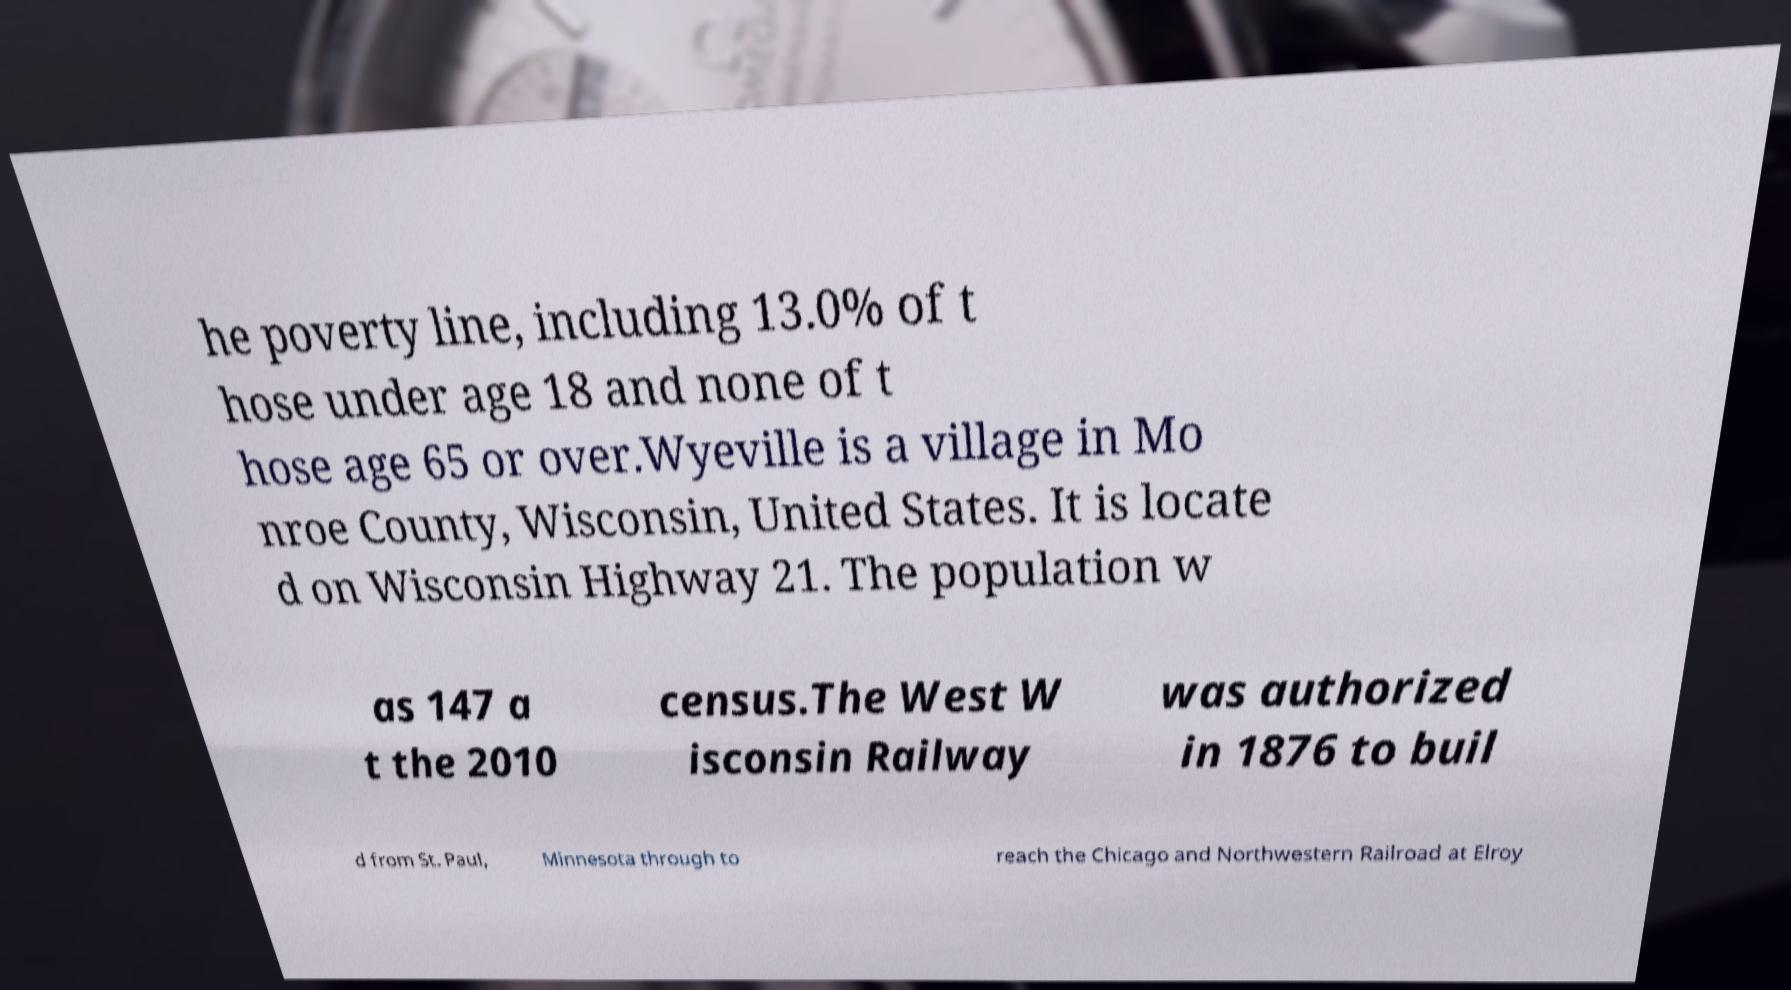Could you extract and type out the text from this image? he poverty line, including 13.0% of t hose under age 18 and none of t hose age 65 or over.Wyeville is a village in Mo nroe County, Wisconsin, United States. It is locate d on Wisconsin Highway 21. The population w as 147 a t the 2010 census.The West W isconsin Railway was authorized in 1876 to buil d from St. Paul, Minnesota through to reach the Chicago and Northwestern Railroad at Elroy 